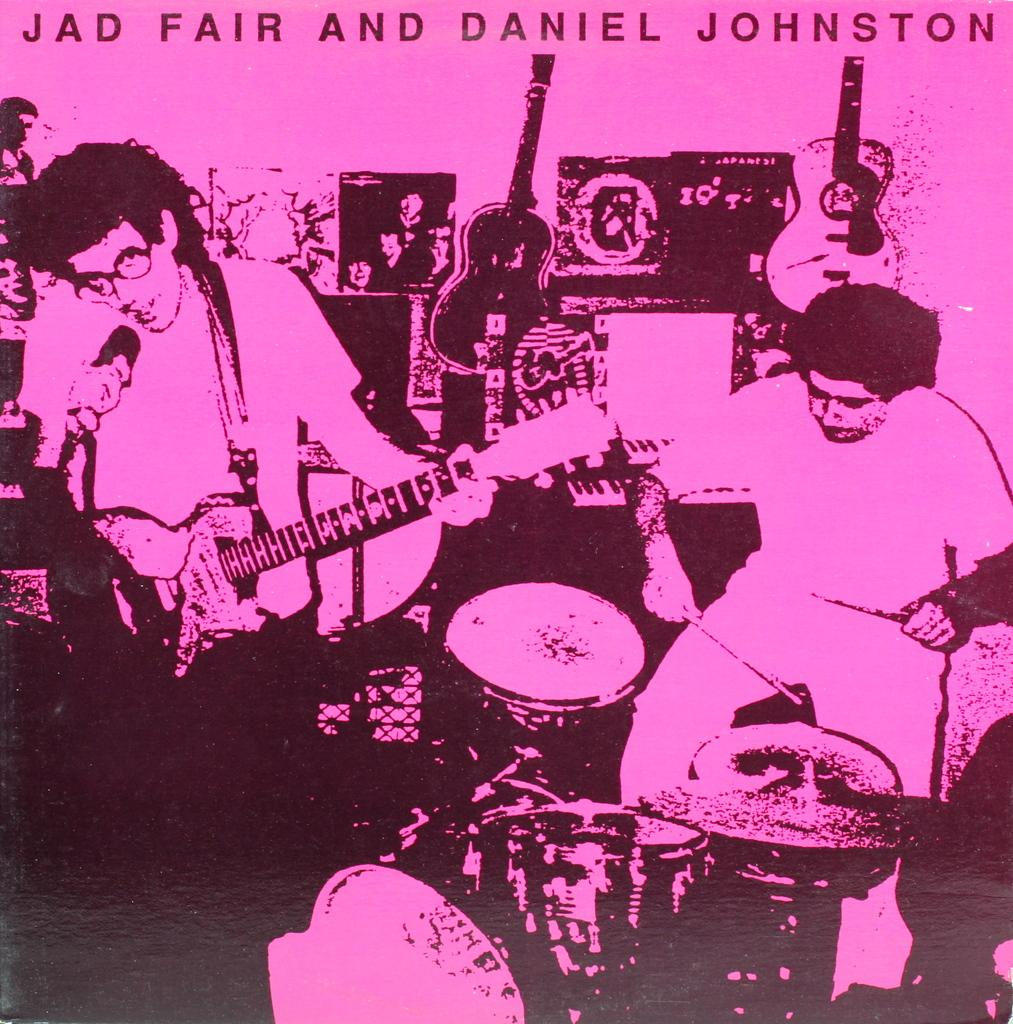What objects are present in the image? There are musical instruments in the image. What are the people in the image doing with the musical instruments? People are playing musical instruments in the image. Where are the people located in the image? There are people on the left side of the image. What can be seen at the top of the image? There is text written at the top of the image. What type of copy machine is visible in the image? There is no copy machine present in the image. How does the stomach of the person playing the musical instrument look in the image? There is no visible indication of the stomach of the person playing the musical instrument in the image. 